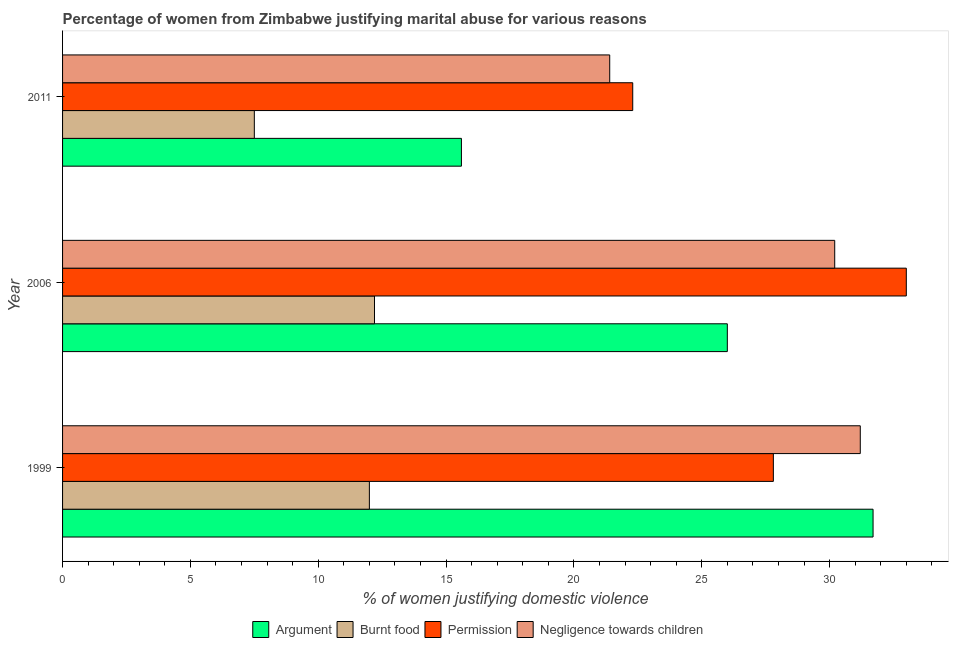How many different coloured bars are there?
Your response must be concise. 4. How many groups of bars are there?
Keep it short and to the point. 3. Are the number of bars on each tick of the Y-axis equal?
Ensure brevity in your answer.  Yes. How many bars are there on the 3rd tick from the top?
Offer a very short reply. 4. Across all years, what is the minimum percentage of women justifying abuse for going without permission?
Ensure brevity in your answer.  22.3. In which year was the percentage of women justifying abuse for going without permission maximum?
Ensure brevity in your answer.  2006. What is the total percentage of women justifying abuse for burning food in the graph?
Your response must be concise. 31.7. What is the difference between the percentage of women justifying abuse in the case of an argument in 2006 and that in 2011?
Your response must be concise. 10.4. What is the difference between the percentage of women justifying abuse for burning food in 1999 and the percentage of women justifying abuse in the case of an argument in 2011?
Provide a succinct answer. -3.6. What is the average percentage of women justifying abuse for burning food per year?
Your response must be concise. 10.57. What is the ratio of the percentage of women justifying abuse for showing negligence towards children in 1999 to that in 2006?
Give a very brief answer. 1.03. Is the percentage of women justifying abuse for going without permission in 2006 less than that in 2011?
Your response must be concise. No. What is the difference between the highest and the second highest percentage of women justifying abuse for burning food?
Ensure brevity in your answer.  0.2. What is the difference between the highest and the lowest percentage of women justifying abuse in the case of an argument?
Your answer should be very brief. 16.1. What does the 2nd bar from the top in 1999 represents?
Make the answer very short. Permission. What does the 3rd bar from the bottom in 2006 represents?
Offer a very short reply. Permission. Is it the case that in every year, the sum of the percentage of women justifying abuse in the case of an argument and percentage of women justifying abuse for burning food is greater than the percentage of women justifying abuse for going without permission?
Ensure brevity in your answer.  Yes. How many bars are there?
Ensure brevity in your answer.  12. What is the difference between two consecutive major ticks on the X-axis?
Provide a succinct answer. 5. Where does the legend appear in the graph?
Your answer should be very brief. Bottom center. How are the legend labels stacked?
Provide a succinct answer. Horizontal. What is the title of the graph?
Give a very brief answer. Percentage of women from Zimbabwe justifying marital abuse for various reasons. What is the label or title of the X-axis?
Provide a short and direct response. % of women justifying domestic violence. What is the label or title of the Y-axis?
Offer a terse response. Year. What is the % of women justifying domestic violence of Argument in 1999?
Provide a succinct answer. 31.7. What is the % of women justifying domestic violence in Permission in 1999?
Keep it short and to the point. 27.8. What is the % of women justifying domestic violence in Negligence towards children in 1999?
Your answer should be very brief. 31.2. What is the % of women justifying domestic violence in Argument in 2006?
Provide a short and direct response. 26. What is the % of women justifying domestic violence in Burnt food in 2006?
Your answer should be very brief. 12.2. What is the % of women justifying domestic violence in Negligence towards children in 2006?
Provide a short and direct response. 30.2. What is the % of women justifying domestic violence in Burnt food in 2011?
Offer a very short reply. 7.5. What is the % of women justifying domestic violence of Permission in 2011?
Offer a very short reply. 22.3. What is the % of women justifying domestic violence of Negligence towards children in 2011?
Make the answer very short. 21.4. Across all years, what is the maximum % of women justifying domestic violence of Argument?
Make the answer very short. 31.7. Across all years, what is the maximum % of women justifying domestic violence in Negligence towards children?
Make the answer very short. 31.2. Across all years, what is the minimum % of women justifying domestic violence of Argument?
Your response must be concise. 15.6. Across all years, what is the minimum % of women justifying domestic violence of Permission?
Ensure brevity in your answer.  22.3. Across all years, what is the minimum % of women justifying domestic violence of Negligence towards children?
Your answer should be very brief. 21.4. What is the total % of women justifying domestic violence in Argument in the graph?
Your response must be concise. 73.3. What is the total % of women justifying domestic violence of Burnt food in the graph?
Keep it short and to the point. 31.7. What is the total % of women justifying domestic violence of Permission in the graph?
Give a very brief answer. 83.1. What is the total % of women justifying domestic violence in Negligence towards children in the graph?
Ensure brevity in your answer.  82.8. What is the difference between the % of women justifying domestic violence of Argument in 1999 and that in 2006?
Provide a succinct answer. 5.7. What is the difference between the % of women justifying domestic violence in Permission in 1999 and that in 2006?
Provide a succinct answer. -5.2. What is the difference between the % of women justifying domestic violence of Negligence towards children in 1999 and that in 2006?
Keep it short and to the point. 1. What is the difference between the % of women justifying domestic violence of Argument in 1999 and that in 2011?
Your response must be concise. 16.1. What is the difference between the % of women justifying domestic violence in Permission in 1999 and that in 2011?
Your response must be concise. 5.5. What is the difference between the % of women justifying domestic violence of Negligence towards children in 1999 and that in 2011?
Ensure brevity in your answer.  9.8. What is the difference between the % of women justifying domestic violence in Burnt food in 2006 and that in 2011?
Provide a succinct answer. 4.7. What is the difference between the % of women justifying domestic violence in Argument in 1999 and the % of women justifying domestic violence in Burnt food in 2006?
Offer a very short reply. 19.5. What is the difference between the % of women justifying domestic violence of Argument in 1999 and the % of women justifying domestic violence of Permission in 2006?
Your answer should be very brief. -1.3. What is the difference between the % of women justifying domestic violence in Argument in 1999 and the % of women justifying domestic violence in Negligence towards children in 2006?
Keep it short and to the point. 1.5. What is the difference between the % of women justifying domestic violence of Burnt food in 1999 and the % of women justifying domestic violence of Permission in 2006?
Your response must be concise. -21. What is the difference between the % of women justifying domestic violence of Burnt food in 1999 and the % of women justifying domestic violence of Negligence towards children in 2006?
Offer a terse response. -18.2. What is the difference between the % of women justifying domestic violence in Permission in 1999 and the % of women justifying domestic violence in Negligence towards children in 2006?
Provide a succinct answer. -2.4. What is the difference between the % of women justifying domestic violence in Argument in 1999 and the % of women justifying domestic violence in Burnt food in 2011?
Your answer should be very brief. 24.2. What is the difference between the % of women justifying domestic violence of Argument in 1999 and the % of women justifying domestic violence of Negligence towards children in 2011?
Your response must be concise. 10.3. What is the difference between the % of women justifying domestic violence of Burnt food in 1999 and the % of women justifying domestic violence of Permission in 2011?
Your answer should be compact. -10.3. What is the difference between the % of women justifying domestic violence of Burnt food in 1999 and the % of women justifying domestic violence of Negligence towards children in 2011?
Your answer should be compact. -9.4. What is the difference between the % of women justifying domestic violence of Permission in 1999 and the % of women justifying domestic violence of Negligence towards children in 2011?
Offer a very short reply. 6.4. What is the difference between the % of women justifying domestic violence of Argument in 2006 and the % of women justifying domestic violence of Permission in 2011?
Keep it short and to the point. 3.7. What is the difference between the % of women justifying domestic violence in Burnt food in 2006 and the % of women justifying domestic violence in Permission in 2011?
Give a very brief answer. -10.1. What is the difference between the % of women justifying domestic violence in Permission in 2006 and the % of women justifying domestic violence in Negligence towards children in 2011?
Your response must be concise. 11.6. What is the average % of women justifying domestic violence of Argument per year?
Provide a short and direct response. 24.43. What is the average % of women justifying domestic violence of Burnt food per year?
Offer a terse response. 10.57. What is the average % of women justifying domestic violence in Permission per year?
Make the answer very short. 27.7. What is the average % of women justifying domestic violence in Negligence towards children per year?
Provide a short and direct response. 27.6. In the year 1999, what is the difference between the % of women justifying domestic violence of Argument and % of women justifying domestic violence of Burnt food?
Make the answer very short. 19.7. In the year 1999, what is the difference between the % of women justifying domestic violence in Argument and % of women justifying domestic violence in Permission?
Ensure brevity in your answer.  3.9. In the year 1999, what is the difference between the % of women justifying domestic violence in Argument and % of women justifying domestic violence in Negligence towards children?
Your answer should be compact. 0.5. In the year 1999, what is the difference between the % of women justifying domestic violence in Burnt food and % of women justifying domestic violence in Permission?
Offer a terse response. -15.8. In the year 1999, what is the difference between the % of women justifying domestic violence of Burnt food and % of women justifying domestic violence of Negligence towards children?
Give a very brief answer. -19.2. In the year 1999, what is the difference between the % of women justifying domestic violence in Permission and % of women justifying domestic violence in Negligence towards children?
Offer a very short reply. -3.4. In the year 2006, what is the difference between the % of women justifying domestic violence in Argument and % of women justifying domestic violence in Permission?
Your answer should be very brief. -7. In the year 2006, what is the difference between the % of women justifying domestic violence of Argument and % of women justifying domestic violence of Negligence towards children?
Your answer should be compact. -4.2. In the year 2006, what is the difference between the % of women justifying domestic violence in Burnt food and % of women justifying domestic violence in Permission?
Your response must be concise. -20.8. In the year 2006, what is the difference between the % of women justifying domestic violence in Burnt food and % of women justifying domestic violence in Negligence towards children?
Provide a succinct answer. -18. In the year 2006, what is the difference between the % of women justifying domestic violence of Permission and % of women justifying domestic violence of Negligence towards children?
Your answer should be compact. 2.8. In the year 2011, what is the difference between the % of women justifying domestic violence of Argument and % of women justifying domestic violence of Burnt food?
Keep it short and to the point. 8.1. In the year 2011, what is the difference between the % of women justifying domestic violence in Argument and % of women justifying domestic violence in Negligence towards children?
Offer a very short reply. -5.8. In the year 2011, what is the difference between the % of women justifying domestic violence of Burnt food and % of women justifying domestic violence of Permission?
Your answer should be very brief. -14.8. What is the ratio of the % of women justifying domestic violence in Argument in 1999 to that in 2006?
Give a very brief answer. 1.22. What is the ratio of the % of women justifying domestic violence in Burnt food in 1999 to that in 2006?
Ensure brevity in your answer.  0.98. What is the ratio of the % of women justifying domestic violence of Permission in 1999 to that in 2006?
Provide a succinct answer. 0.84. What is the ratio of the % of women justifying domestic violence in Negligence towards children in 1999 to that in 2006?
Your response must be concise. 1.03. What is the ratio of the % of women justifying domestic violence in Argument in 1999 to that in 2011?
Give a very brief answer. 2.03. What is the ratio of the % of women justifying domestic violence of Burnt food in 1999 to that in 2011?
Provide a succinct answer. 1.6. What is the ratio of the % of women justifying domestic violence of Permission in 1999 to that in 2011?
Your answer should be compact. 1.25. What is the ratio of the % of women justifying domestic violence in Negligence towards children in 1999 to that in 2011?
Make the answer very short. 1.46. What is the ratio of the % of women justifying domestic violence of Burnt food in 2006 to that in 2011?
Provide a short and direct response. 1.63. What is the ratio of the % of women justifying domestic violence of Permission in 2006 to that in 2011?
Offer a terse response. 1.48. What is the ratio of the % of women justifying domestic violence of Negligence towards children in 2006 to that in 2011?
Make the answer very short. 1.41. What is the difference between the highest and the second highest % of women justifying domestic violence of Permission?
Ensure brevity in your answer.  5.2. What is the difference between the highest and the second highest % of women justifying domestic violence in Negligence towards children?
Give a very brief answer. 1. What is the difference between the highest and the lowest % of women justifying domestic violence of Permission?
Give a very brief answer. 10.7. What is the difference between the highest and the lowest % of women justifying domestic violence in Negligence towards children?
Provide a succinct answer. 9.8. 